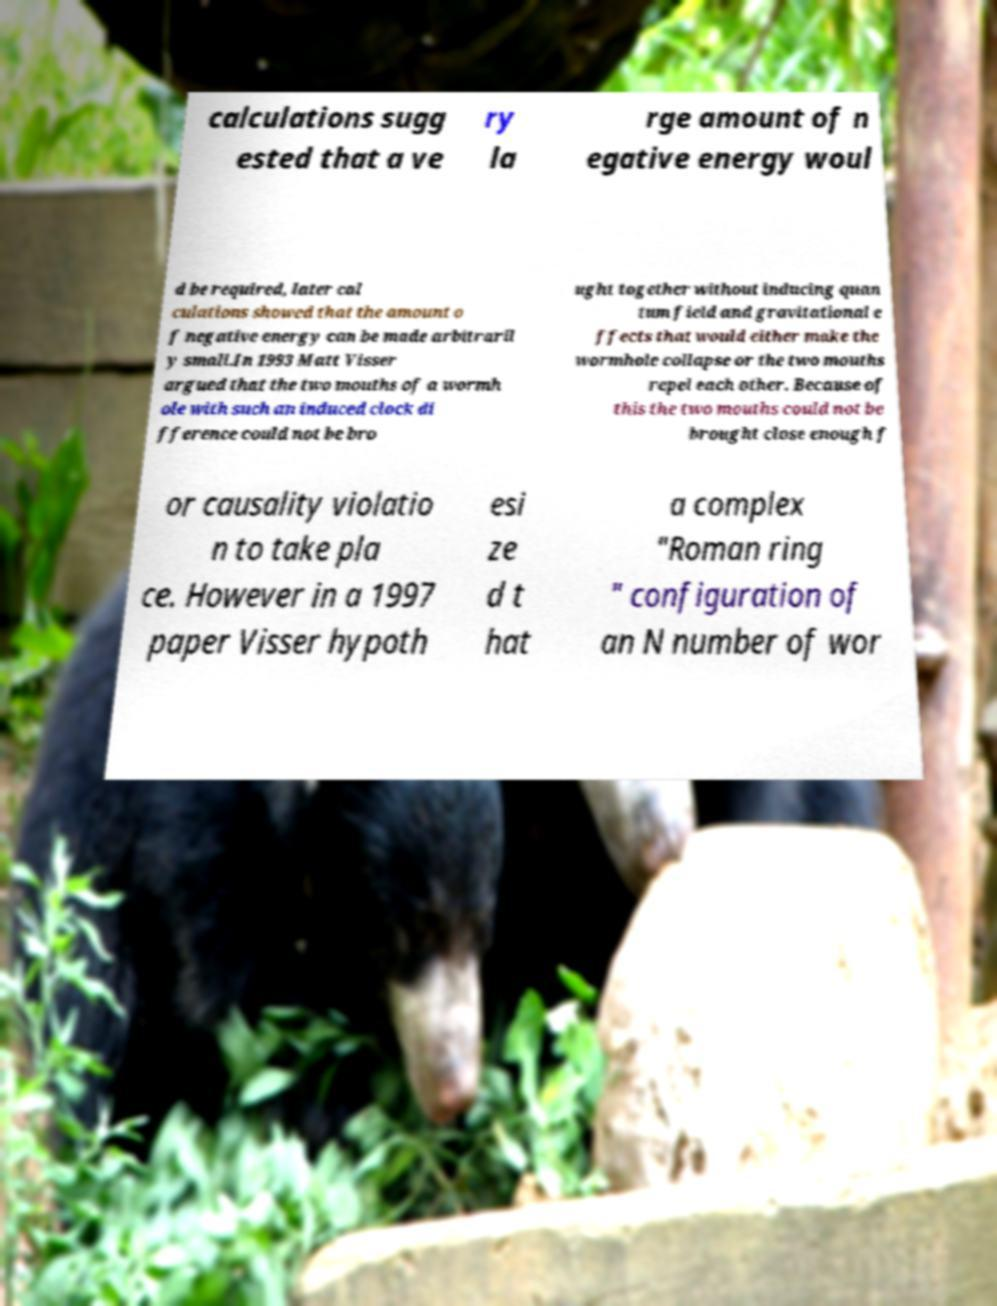Please identify and transcribe the text found in this image. calculations sugg ested that a ve ry la rge amount of n egative energy woul d be required, later cal culations showed that the amount o f negative energy can be made arbitraril y small.In 1993 Matt Visser argued that the two mouths of a wormh ole with such an induced clock di fference could not be bro ught together without inducing quan tum field and gravitational e ffects that would either make the wormhole collapse or the two mouths repel each other. Because of this the two mouths could not be brought close enough f or causality violatio n to take pla ce. However in a 1997 paper Visser hypoth esi ze d t hat a complex "Roman ring " configuration of an N number of wor 